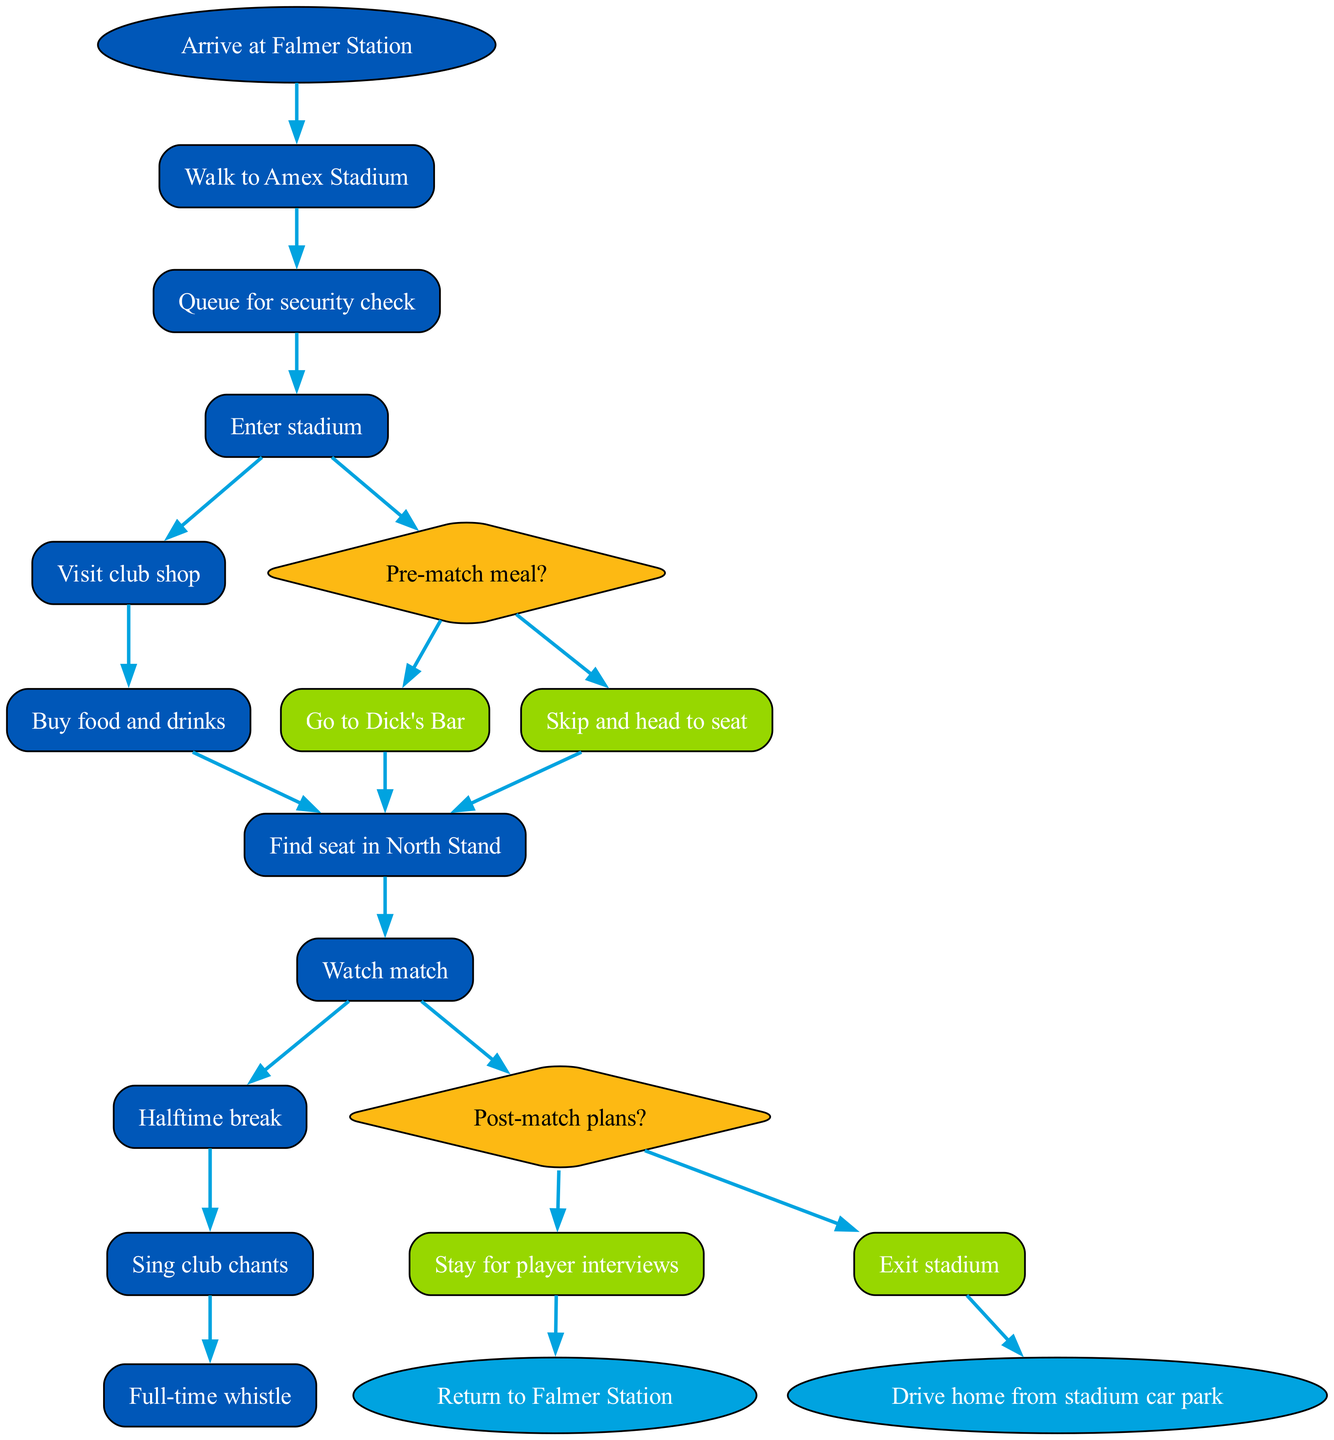What is the first activity after arriving at Falmer Station? The initial node indicates the starting point of the diagram, which is labeled "Arrive at Falmer Station". The first activity that follows is "Walk to Amex Stadium".
Answer: Walk to Amex Stadium How many decision points are there in the diagram? The diagram indicates two decision points: "Pre-match meal?" and "Post-match plans?". Therefore, the count of decision points is two.
Answer: 2 What are the two options available for the decision point "Pre-match meal?" This decision point is indicated in the diagram alongside the options "Go to Dick's Bar" and "Skip and head to seat", which are presented as choices leading to different subsequent actions.
Answer: Go to Dick's Bar, Skip and head to seat What activity occurs immediately after "Buy food and drinks"? According to the sequence of activities in the diagram, "Find seat in North Stand" is the next activity that occurs right after "Buy food and drinks".
Answer: Find seat in North Stand Which activity precedes the decision point "Post-match plans?" The activity just before the decision point "Post-match plans?" is "Full-time whistle", as per the arrangement of activities in the diagram. This shows the flow of actions leading to the decision.
Answer: Full-time whistle If the option "Stay for player interviews" is chosen after the match, what will the next activity be? If the option "Stay for player interviews" is selected at the "Post-match plans?" decision point, the diagram indicates no further activities or nodes after this decision, implying the match day ends with this option.
Answer: None How many total activities are listed in the diagram? The activities are enumerated in the diagram, totaling to ten distinct activities specified within the outlined flow.
Answer: 10 What color represents the decision nodes in the diagram? Decision nodes are visually indicated in the diagram using a specific color, which is yellow, as indicated by the fill color marked as "#FDB913".
Answer: Yellow 